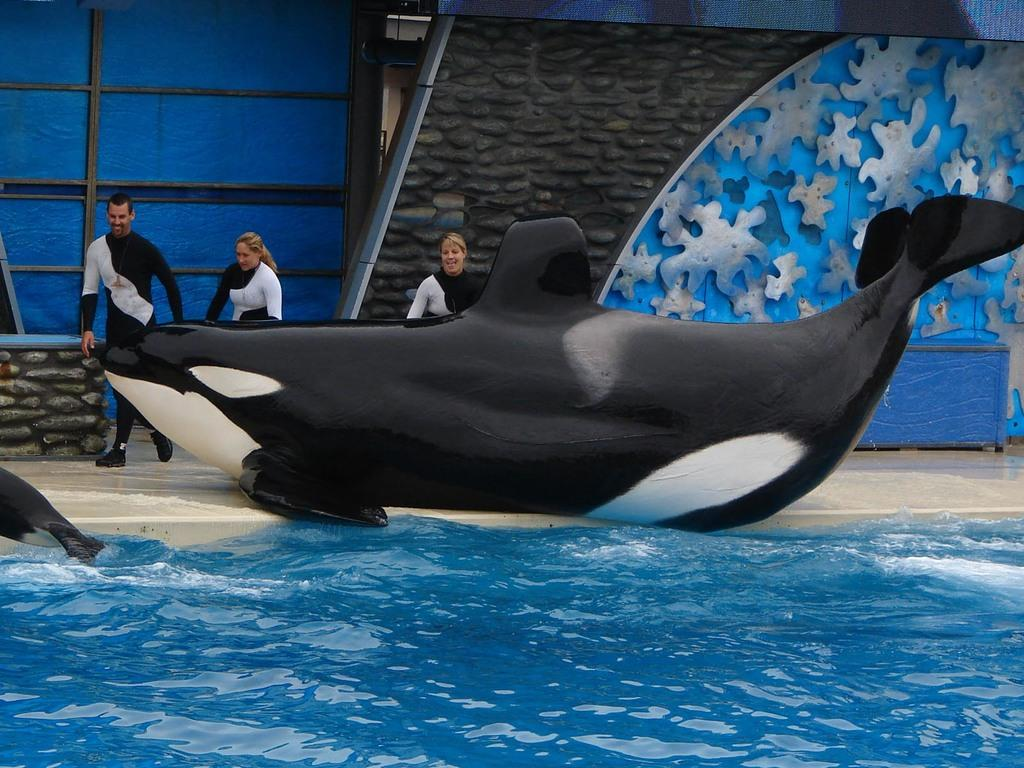What animals can be seen in the image? There are two fishes in the image. What is the primary element in which the fishes are situated? There is water visible in the image, and the fishes are in the water. What type of barrier is present in the image? There is a fence in the image. What can be seen in the background of the image? In the background, there are three persons and a wall. What type of material is present in the background? Metal rods are present in the background. Can you determine the time of day when the image was taken? The image was likely taken during the day, as there is sufficient light to see the details clearly. What color is the crayon used to draw the fishes in the image? There is no crayon or drawing present in the image; it is a photograph of real fishes in water. What month was the image taken in? The month cannot be determined from the image, as there is no specific information about the time of year. 